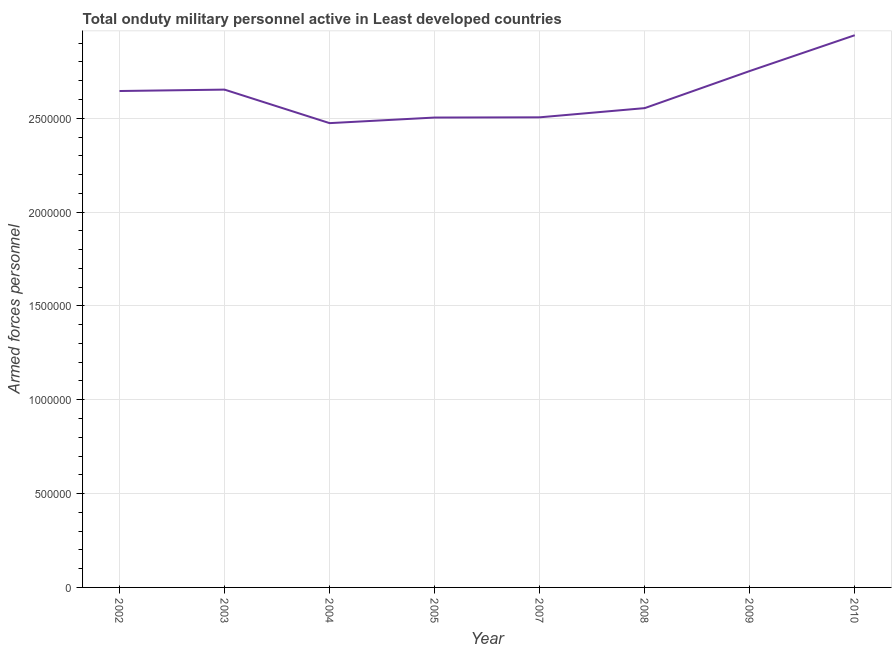What is the number of armed forces personnel in 2009?
Provide a short and direct response. 2.75e+06. Across all years, what is the maximum number of armed forces personnel?
Ensure brevity in your answer.  2.94e+06. Across all years, what is the minimum number of armed forces personnel?
Ensure brevity in your answer.  2.47e+06. In which year was the number of armed forces personnel maximum?
Keep it short and to the point. 2010. What is the sum of the number of armed forces personnel?
Your answer should be compact. 2.10e+07. What is the difference between the number of armed forces personnel in 2008 and 2010?
Make the answer very short. -3.88e+05. What is the average number of armed forces personnel per year?
Keep it short and to the point. 2.63e+06. What is the median number of armed forces personnel?
Provide a short and direct response. 2.60e+06. Do a majority of the years between 2009 and 2007 (inclusive) have number of armed forces personnel greater than 1400000 ?
Provide a short and direct response. No. What is the ratio of the number of armed forces personnel in 2005 to that in 2008?
Ensure brevity in your answer.  0.98. Is the number of armed forces personnel in 2005 less than that in 2010?
Ensure brevity in your answer.  Yes. Is the difference between the number of armed forces personnel in 2002 and 2005 greater than the difference between any two years?
Give a very brief answer. No. What is the difference between the highest and the second highest number of armed forces personnel?
Provide a succinct answer. 1.91e+05. Is the sum of the number of armed forces personnel in 2008 and 2009 greater than the maximum number of armed forces personnel across all years?
Your answer should be compact. Yes. What is the difference between the highest and the lowest number of armed forces personnel?
Keep it short and to the point. 4.68e+05. Does the number of armed forces personnel monotonically increase over the years?
Offer a terse response. No. How many lines are there?
Offer a terse response. 1. How many years are there in the graph?
Provide a short and direct response. 8. What is the difference between two consecutive major ticks on the Y-axis?
Offer a terse response. 5.00e+05. Does the graph contain any zero values?
Keep it short and to the point. No. Does the graph contain grids?
Give a very brief answer. Yes. What is the title of the graph?
Provide a succinct answer. Total onduty military personnel active in Least developed countries. What is the label or title of the Y-axis?
Your answer should be very brief. Armed forces personnel. What is the Armed forces personnel of 2002?
Your answer should be very brief. 2.65e+06. What is the Armed forces personnel in 2003?
Your answer should be very brief. 2.65e+06. What is the Armed forces personnel in 2004?
Offer a terse response. 2.47e+06. What is the Armed forces personnel in 2005?
Offer a very short reply. 2.50e+06. What is the Armed forces personnel of 2007?
Give a very brief answer. 2.50e+06. What is the Armed forces personnel in 2008?
Ensure brevity in your answer.  2.55e+06. What is the Armed forces personnel in 2009?
Your response must be concise. 2.75e+06. What is the Armed forces personnel in 2010?
Provide a succinct answer. 2.94e+06. What is the difference between the Armed forces personnel in 2002 and 2003?
Keep it short and to the point. -7550. What is the difference between the Armed forces personnel in 2002 and 2004?
Make the answer very short. 1.71e+05. What is the difference between the Armed forces personnel in 2002 and 2005?
Provide a short and direct response. 1.41e+05. What is the difference between the Armed forces personnel in 2002 and 2007?
Give a very brief answer. 1.40e+05. What is the difference between the Armed forces personnel in 2002 and 2008?
Provide a short and direct response. 9.12e+04. What is the difference between the Armed forces personnel in 2002 and 2009?
Offer a terse response. -1.06e+05. What is the difference between the Armed forces personnel in 2002 and 2010?
Keep it short and to the point. -2.97e+05. What is the difference between the Armed forces personnel in 2003 and 2004?
Provide a short and direct response. 1.79e+05. What is the difference between the Armed forces personnel in 2003 and 2005?
Offer a terse response. 1.49e+05. What is the difference between the Armed forces personnel in 2003 and 2007?
Offer a terse response. 1.48e+05. What is the difference between the Armed forces personnel in 2003 and 2008?
Offer a terse response. 9.87e+04. What is the difference between the Armed forces personnel in 2003 and 2009?
Offer a very short reply. -9.89e+04. What is the difference between the Armed forces personnel in 2003 and 2010?
Offer a terse response. -2.90e+05. What is the difference between the Armed forces personnel in 2004 and 2005?
Keep it short and to the point. -2.98e+04. What is the difference between the Armed forces personnel in 2004 and 2007?
Ensure brevity in your answer.  -3.10e+04. What is the difference between the Armed forces personnel in 2004 and 2008?
Ensure brevity in your answer.  -8.00e+04. What is the difference between the Armed forces personnel in 2004 and 2009?
Provide a succinct answer. -2.78e+05. What is the difference between the Armed forces personnel in 2004 and 2010?
Your answer should be compact. -4.68e+05. What is the difference between the Armed forces personnel in 2005 and 2007?
Your response must be concise. -1200. What is the difference between the Armed forces personnel in 2005 and 2008?
Your response must be concise. -5.02e+04. What is the difference between the Armed forces personnel in 2005 and 2009?
Your answer should be compact. -2.48e+05. What is the difference between the Armed forces personnel in 2005 and 2010?
Make the answer very short. -4.39e+05. What is the difference between the Armed forces personnel in 2007 and 2008?
Keep it short and to the point. -4.90e+04. What is the difference between the Armed forces personnel in 2007 and 2009?
Make the answer very short. -2.47e+05. What is the difference between the Armed forces personnel in 2007 and 2010?
Offer a very short reply. -4.37e+05. What is the difference between the Armed forces personnel in 2008 and 2009?
Provide a short and direct response. -1.98e+05. What is the difference between the Armed forces personnel in 2008 and 2010?
Your response must be concise. -3.88e+05. What is the difference between the Armed forces personnel in 2009 and 2010?
Make the answer very short. -1.91e+05. What is the ratio of the Armed forces personnel in 2002 to that in 2003?
Provide a succinct answer. 1. What is the ratio of the Armed forces personnel in 2002 to that in 2004?
Your answer should be very brief. 1.07. What is the ratio of the Armed forces personnel in 2002 to that in 2005?
Keep it short and to the point. 1.06. What is the ratio of the Armed forces personnel in 2002 to that in 2007?
Give a very brief answer. 1.06. What is the ratio of the Armed forces personnel in 2002 to that in 2008?
Make the answer very short. 1.04. What is the ratio of the Armed forces personnel in 2002 to that in 2010?
Your answer should be very brief. 0.9. What is the ratio of the Armed forces personnel in 2003 to that in 2004?
Your answer should be compact. 1.07. What is the ratio of the Armed forces personnel in 2003 to that in 2005?
Provide a succinct answer. 1.06. What is the ratio of the Armed forces personnel in 2003 to that in 2007?
Provide a succinct answer. 1.06. What is the ratio of the Armed forces personnel in 2003 to that in 2008?
Ensure brevity in your answer.  1.04. What is the ratio of the Armed forces personnel in 2003 to that in 2010?
Provide a succinct answer. 0.9. What is the ratio of the Armed forces personnel in 2004 to that in 2005?
Ensure brevity in your answer.  0.99. What is the ratio of the Armed forces personnel in 2004 to that in 2007?
Offer a very short reply. 0.99. What is the ratio of the Armed forces personnel in 2004 to that in 2009?
Offer a very short reply. 0.9. What is the ratio of the Armed forces personnel in 2004 to that in 2010?
Offer a terse response. 0.84. What is the ratio of the Armed forces personnel in 2005 to that in 2007?
Make the answer very short. 1. What is the ratio of the Armed forces personnel in 2005 to that in 2008?
Keep it short and to the point. 0.98. What is the ratio of the Armed forces personnel in 2005 to that in 2009?
Ensure brevity in your answer.  0.91. What is the ratio of the Armed forces personnel in 2005 to that in 2010?
Keep it short and to the point. 0.85. What is the ratio of the Armed forces personnel in 2007 to that in 2008?
Offer a terse response. 0.98. What is the ratio of the Armed forces personnel in 2007 to that in 2009?
Provide a short and direct response. 0.91. What is the ratio of the Armed forces personnel in 2007 to that in 2010?
Ensure brevity in your answer.  0.85. What is the ratio of the Armed forces personnel in 2008 to that in 2009?
Give a very brief answer. 0.93. What is the ratio of the Armed forces personnel in 2008 to that in 2010?
Keep it short and to the point. 0.87. What is the ratio of the Armed forces personnel in 2009 to that in 2010?
Keep it short and to the point. 0.94. 